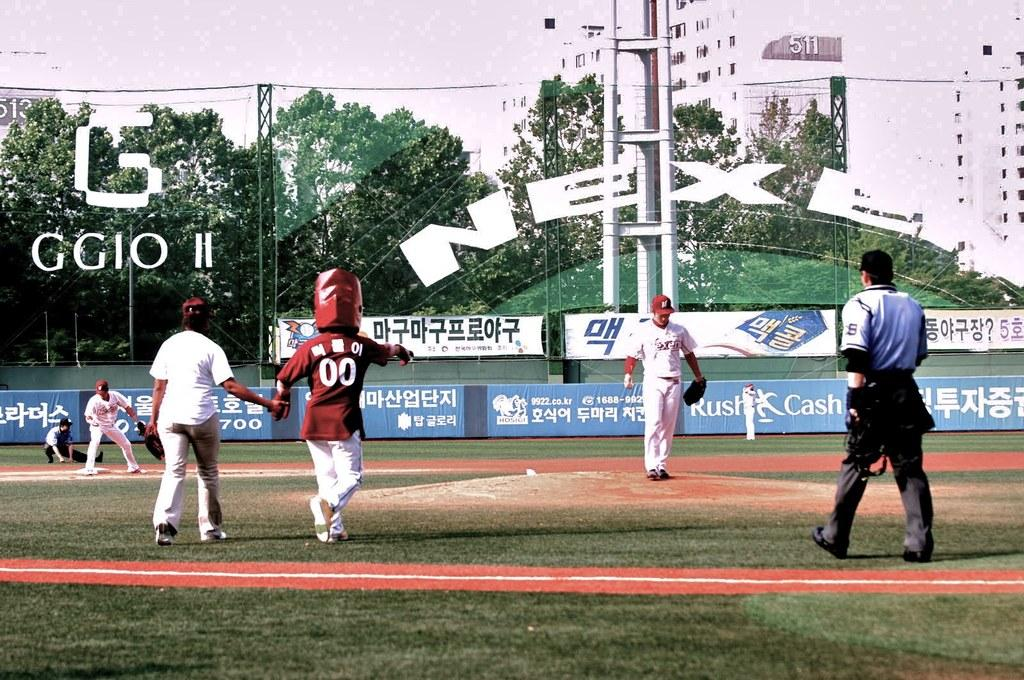Provide a one-sentence caption for the provided image. A Korean baseball field has a blue advertisement for Rush Cash. 